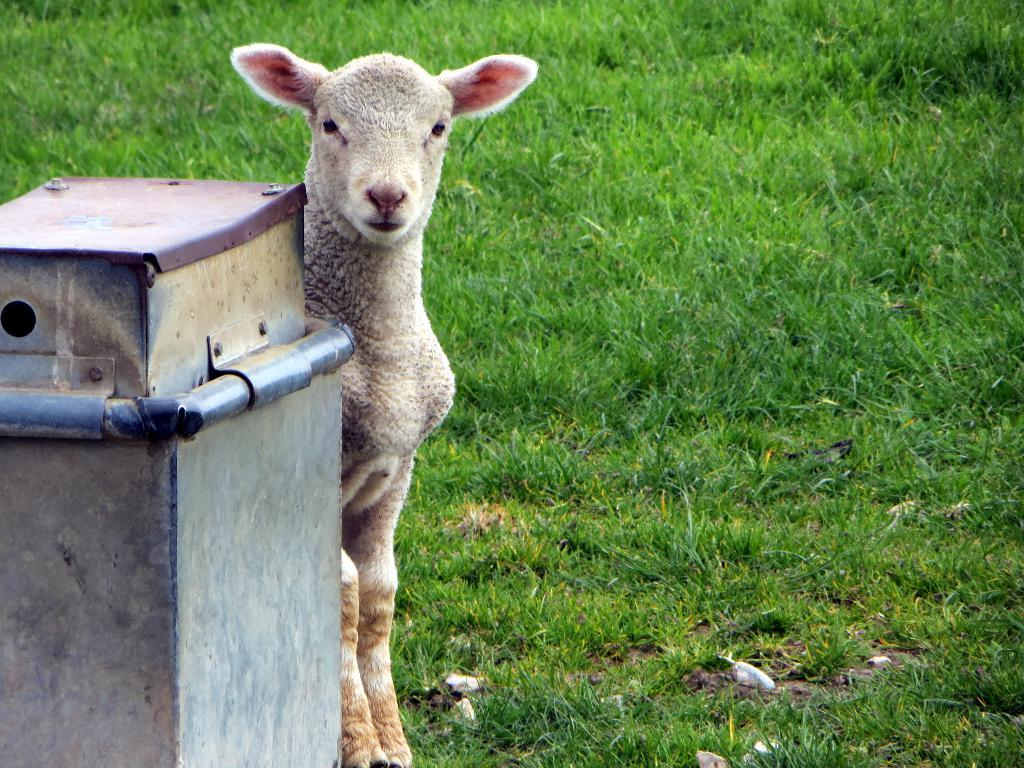What type of vegetation covers the land in the image? The land is covered with grass. What can be seen besides the grass in the image? There is a machine in the image. Can you describe the relationship between the machine and the animal in the image? The animal is present in the image, with the machine in front of it. What time of day is it in the image? The time of day is not mentioned or depicted in the image, so it cannot be determined. 